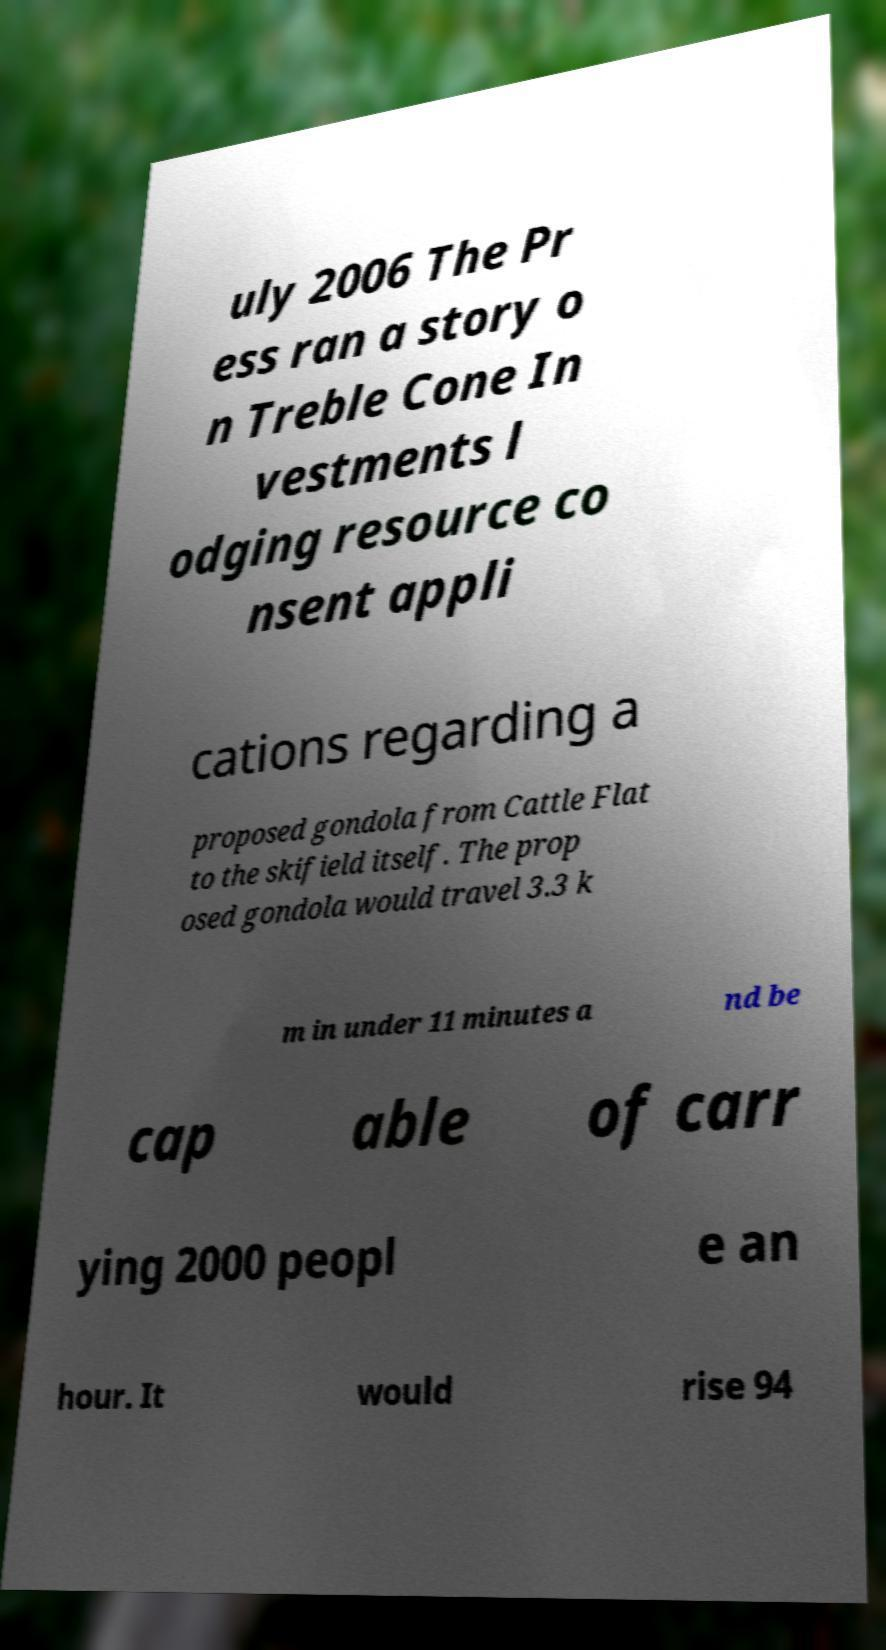For documentation purposes, I need the text within this image transcribed. Could you provide that? uly 2006 The Pr ess ran a story o n Treble Cone In vestments l odging resource co nsent appli cations regarding a proposed gondola from Cattle Flat to the skifield itself. The prop osed gondola would travel 3.3 k m in under 11 minutes a nd be cap able of carr ying 2000 peopl e an hour. It would rise 94 